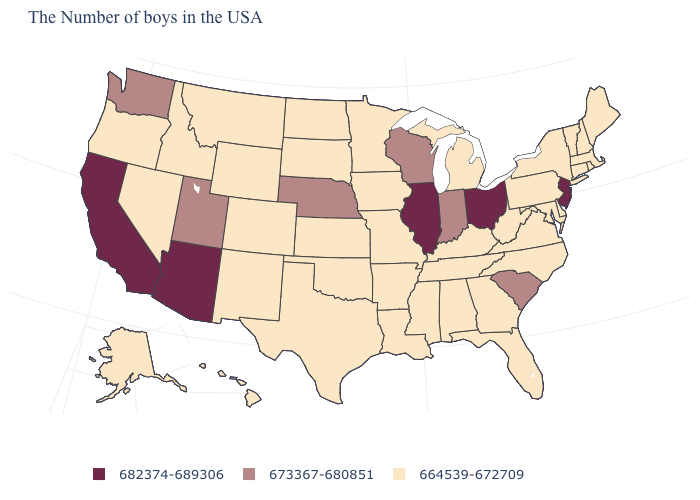What is the value of Alaska?
Give a very brief answer. 664539-672709. What is the value of Ohio?
Be succinct. 682374-689306. What is the value of New York?
Give a very brief answer. 664539-672709. What is the lowest value in the USA?
Be succinct. 664539-672709. Name the states that have a value in the range 664539-672709?
Answer briefly. Maine, Massachusetts, Rhode Island, New Hampshire, Vermont, Connecticut, New York, Delaware, Maryland, Pennsylvania, Virginia, North Carolina, West Virginia, Florida, Georgia, Michigan, Kentucky, Alabama, Tennessee, Mississippi, Louisiana, Missouri, Arkansas, Minnesota, Iowa, Kansas, Oklahoma, Texas, South Dakota, North Dakota, Wyoming, Colorado, New Mexico, Montana, Idaho, Nevada, Oregon, Alaska, Hawaii. Does South Carolina have the highest value in the South?
Write a very short answer. Yes. Does Wyoming have the lowest value in the West?
Answer briefly. Yes. Which states have the lowest value in the USA?
Short answer required. Maine, Massachusetts, Rhode Island, New Hampshire, Vermont, Connecticut, New York, Delaware, Maryland, Pennsylvania, Virginia, North Carolina, West Virginia, Florida, Georgia, Michigan, Kentucky, Alabama, Tennessee, Mississippi, Louisiana, Missouri, Arkansas, Minnesota, Iowa, Kansas, Oklahoma, Texas, South Dakota, North Dakota, Wyoming, Colorado, New Mexico, Montana, Idaho, Nevada, Oregon, Alaska, Hawaii. Does New Jersey have the lowest value in the Northeast?
Keep it brief. No. Name the states that have a value in the range 682374-689306?
Answer briefly. New Jersey, Ohio, Illinois, Arizona, California. How many symbols are there in the legend?
Concise answer only. 3. Does Indiana have the lowest value in the USA?
Keep it brief. No. Does Wisconsin have the same value as South Carolina?
Write a very short answer. Yes. 